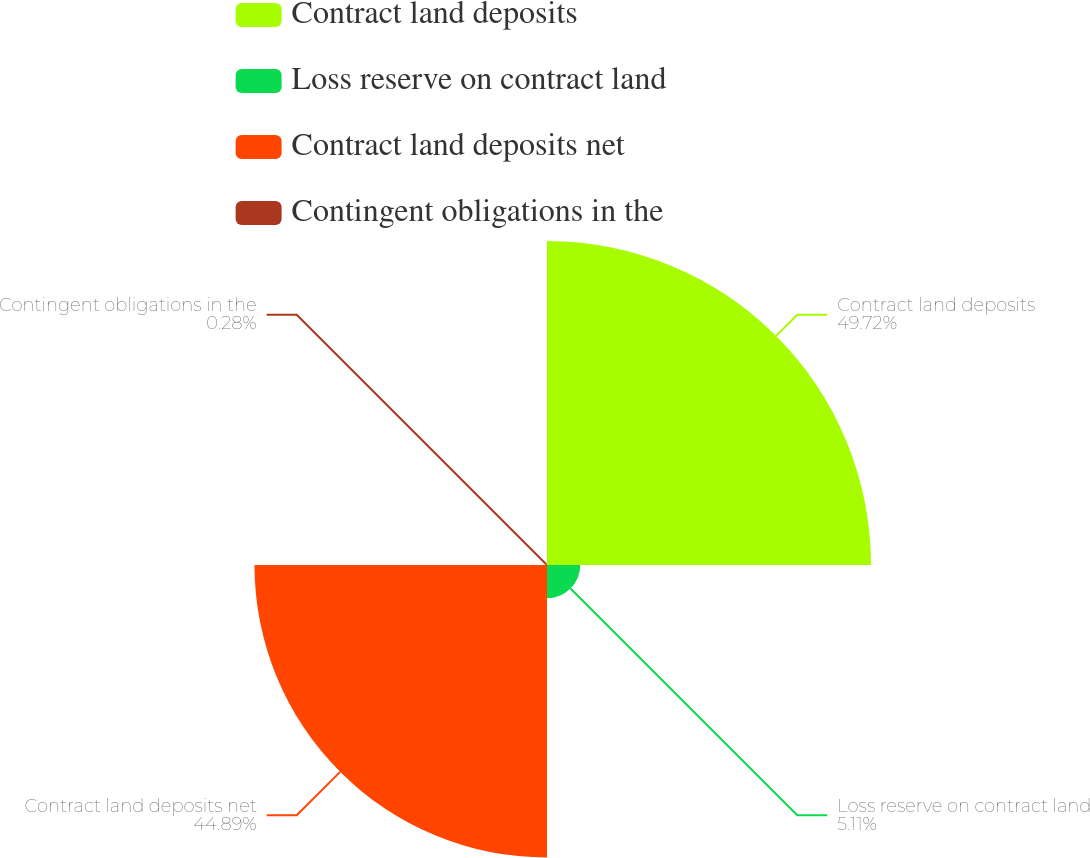Convert chart to OTSL. <chart><loc_0><loc_0><loc_500><loc_500><pie_chart><fcel>Contract land deposits<fcel>Loss reserve on contract land<fcel>Contract land deposits net<fcel>Contingent obligations in the<nl><fcel>49.72%<fcel>5.11%<fcel>44.89%<fcel>0.28%<nl></chart> 